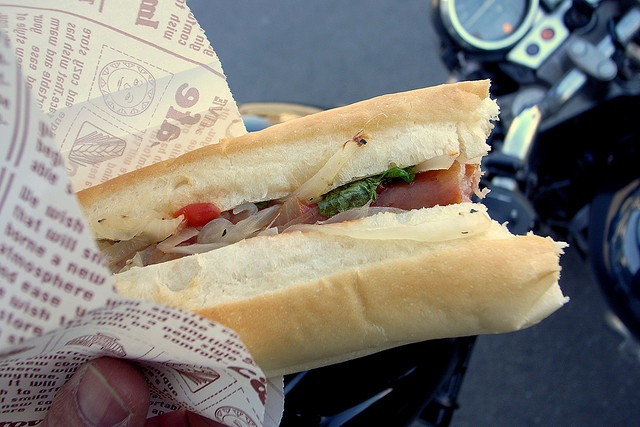Describe the objects in this image and their specific colors. I can see hot dog in lightgray and tan tones, motorcycle in lightgray, black, navy, gray, and blue tones, and people in lightgray, maroon, brown, black, and purple tones in this image. 